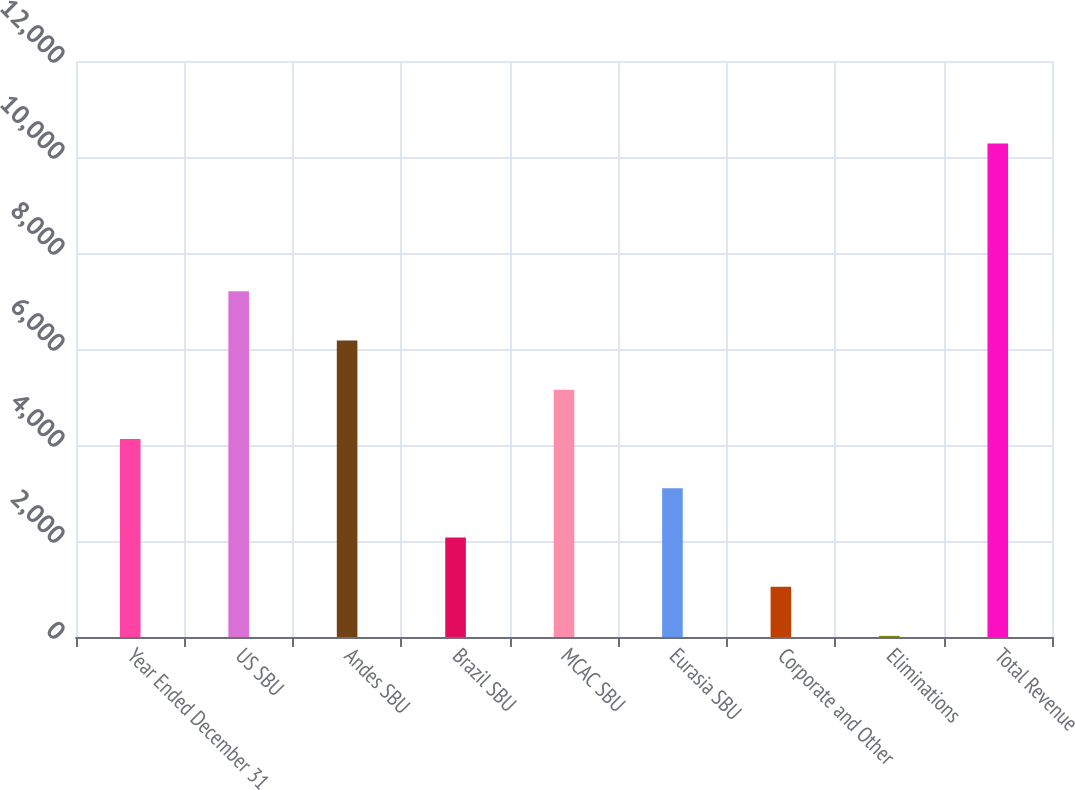Convert chart. <chart><loc_0><loc_0><loc_500><loc_500><bar_chart><fcel>Year Ended December 31<fcel>US SBU<fcel>Andes SBU<fcel>Brazil SBU<fcel>MCAC SBU<fcel>Eurasia SBU<fcel>Corporate and Other<fcel>Eliminations<fcel>Total Revenue<nl><fcel>4126.2<fcel>7203.6<fcel>6177.8<fcel>2074.6<fcel>5152<fcel>3100.4<fcel>1048.8<fcel>23<fcel>10281<nl></chart> 